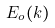<formula> <loc_0><loc_0><loc_500><loc_500>E _ { o } ( k )</formula> 